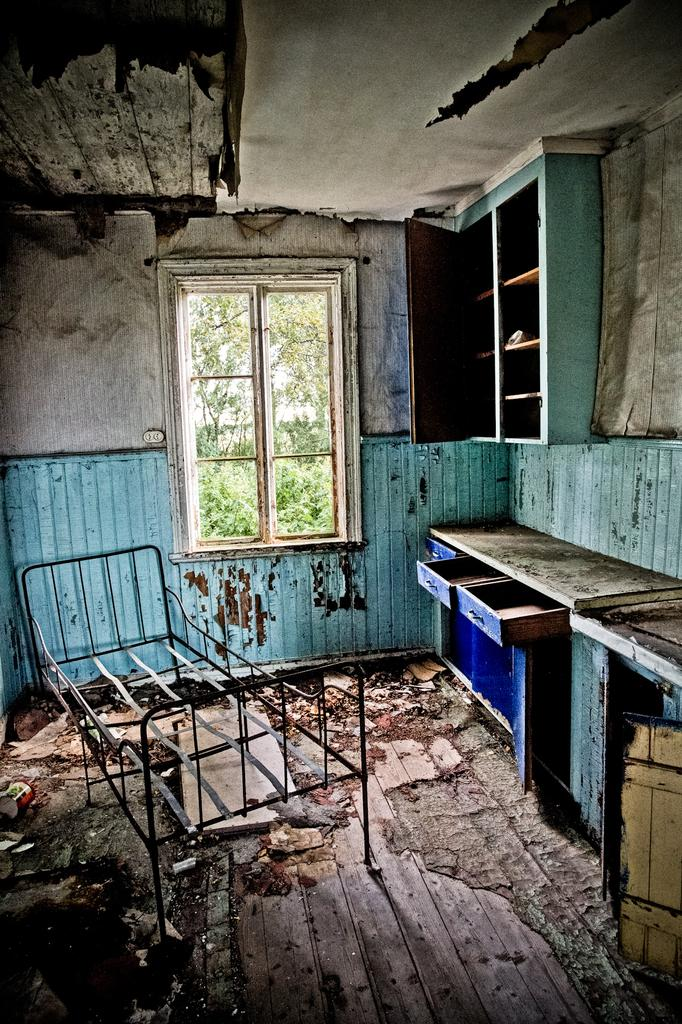What is the condition of the room in the image? The room appears to be destructed. What type of furniture is present in the room? There is a metal cot in the room. What is one of the walls made of? The room has a wall. What can be seen through the window in the room? Trees are visible through the window. What part of the room is visible from above? The ceiling is visible in the room. What type of storage furniture is in the room? There are cupboards in the room. What type of jewel is the child wearing in the image? There is no child or jewel present in the image. What type of juice is being served in the room? There is no juice or serving activity present in the image. 